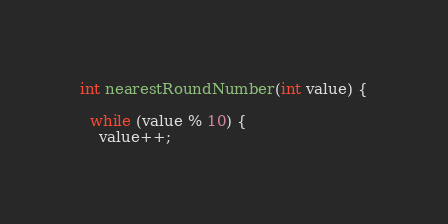Convert code to text. <code><loc_0><loc_0><loc_500><loc_500><_C++_>int nearestRoundNumber(int value) {

  while (value % 10) {
    value++;</code> 